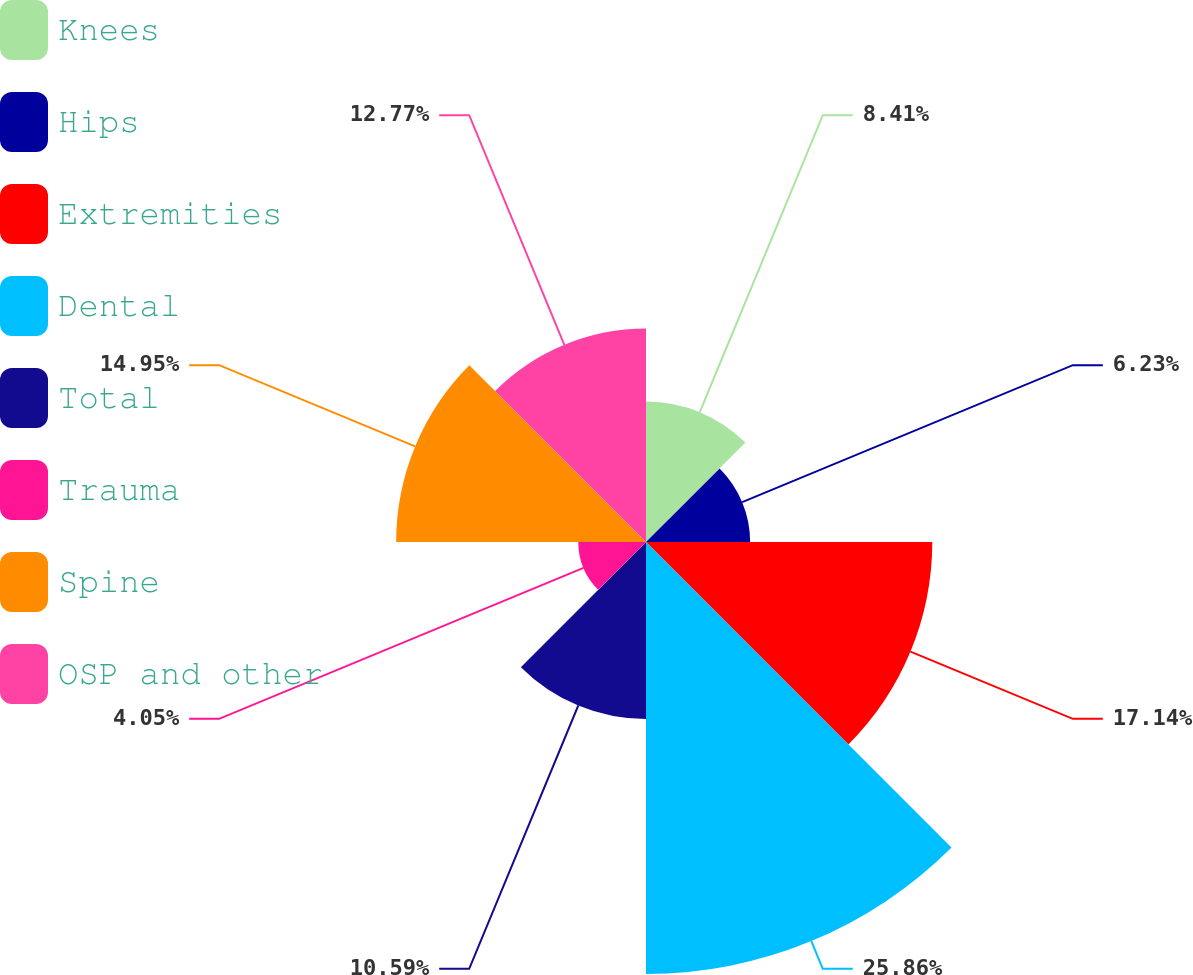Convert chart to OTSL. <chart><loc_0><loc_0><loc_500><loc_500><pie_chart><fcel>Knees<fcel>Hips<fcel>Extremities<fcel>Dental<fcel>Total<fcel>Trauma<fcel>Spine<fcel>OSP and other<nl><fcel>8.41%<fcel>6.23%<fcel>17.13%<fcel>25.85%<fcel>10.59%<fcel>4.05%<fcel>14.95%<fcel>12.77%<nl></chart> 